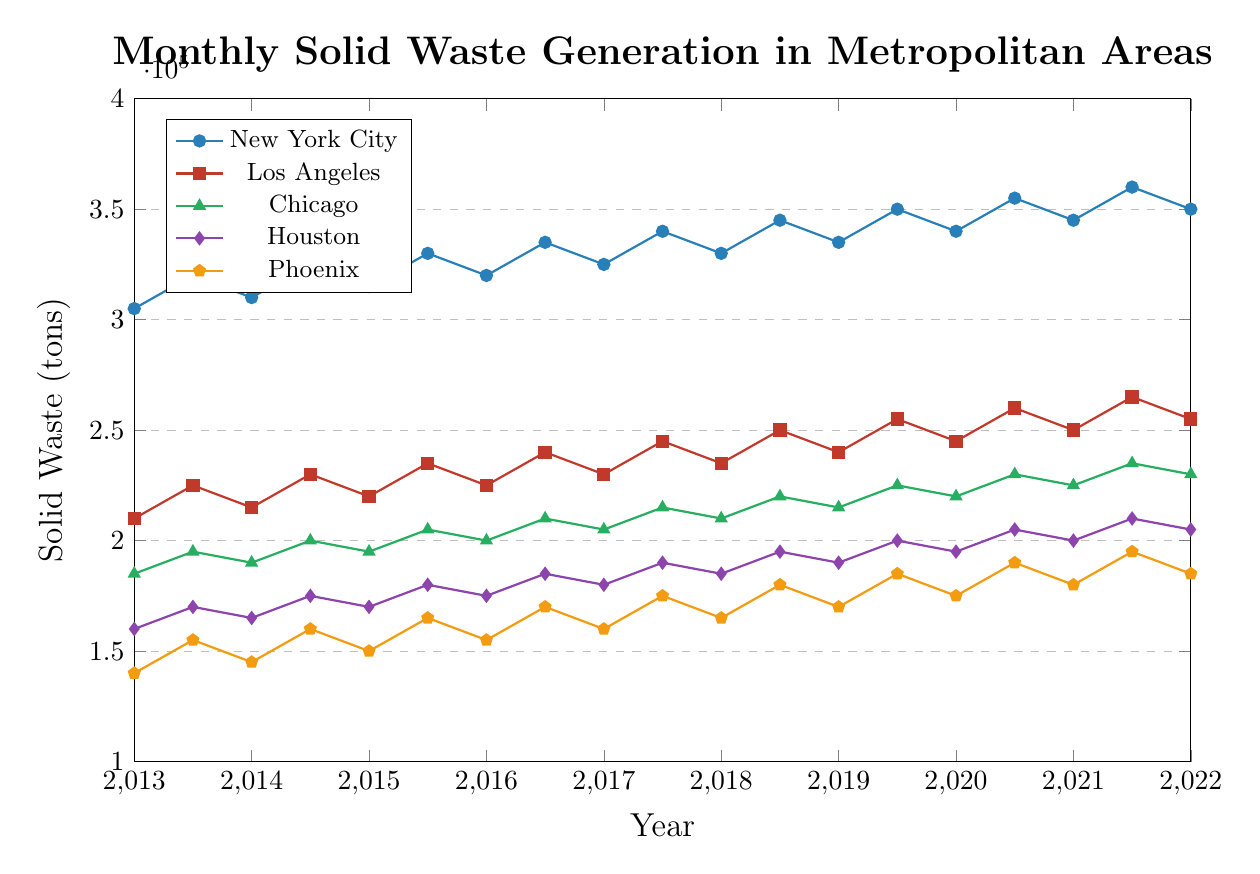Which city shows the highest solid waste generation throughout the 10-year period? New York City consistently shows the highest solid waste generation across the 10-year period as depicted by the uppermost blue line in the chart.
Answer: New York City What is the difference in solid waste generation between New York City and Los Angeles in July 2022? The chart shows that in July 2022, New York City generated 365,000 tons of solid waste while Los Angeles generated 270,000 tons. The difference between them is 365,000 - 270,000 = 95,000 tons.
Answer: 95,000 tons Which city experienced the steepest increase in solid waste generation from January 2013 to July 2022? By examining the slopes of the lines, New York City displays the steepest increase in solid waste generation from 305,000 tons in January 2013 to 365,000 tons in July 2022, reflecting an increase of 60,000 tons.
Answer: New York City Did Phoenix ever generate more solid waste than Houston during the 10-year period? By inspecting the chart, Phoenix's line (orange) is consistently below Houston's line (purple), indicating that Phoenix never generated more solid waste than Houston.
Answer: No What's the average solid waste generation for Chicago from January 2013 to July 2022? To find the average, sum all the solid waste generation values for Chicago from the chart and divide by the number of data points: (185,000 + 195,000 + 190,000 + 200,000 + 195,000 + 205,000 + 200,000 + 210,000 + 205,000 + 215,000 + 210,000 + 220,000 + 215,000 + 225,000 + 220,000 + 230,000 + 225,000 + 235,000 + 230,000 + 240,000)/20 = 212,500 tons.
Answer: 212,500 tons How does the solid waste generation trend in Houston compare to Phoenix from 2013 to 2022? Both cities show an increasing trend, but Houston starts and ends at higher values than Phoenix across the period. Phoenix's increase is from 140,000 tons to 200,000 tons, while Houston’s increase is from 160,000 tons to 215,000 tons. Houston also shows larger increments in solid waste generation over time compared to Phoenix.
Answer: Houston's trend is higher and incrementally larger than Phoenix's In which year and month was the generation of solid waste the highest for Los Angeles? According to the chart, Los Angeles reached its highest solid waste generation in July 2022 with 270,000 tons.
Answer: July 2022 What is the total increase in solid waste generation for New York City from January 2013 to July 2022? The solid waste generation in New York City in January 2013 was 305,000 tons and in July 2022 it was 365,000 tons. The total increase is 365,000 - 305,000 = 60,000 tons.
Answer: 60,000 tons Which two cities had the smallest difference in solid waste generation in January 2022? In January 2022, the chart indicates that Houston (205,000 tons) and Chicago (230,000 tons) have the smallest difference in solid waste generation, which is 230,000 - 205,000 = 25,000 tons.
Answer: Houston and Chicago 